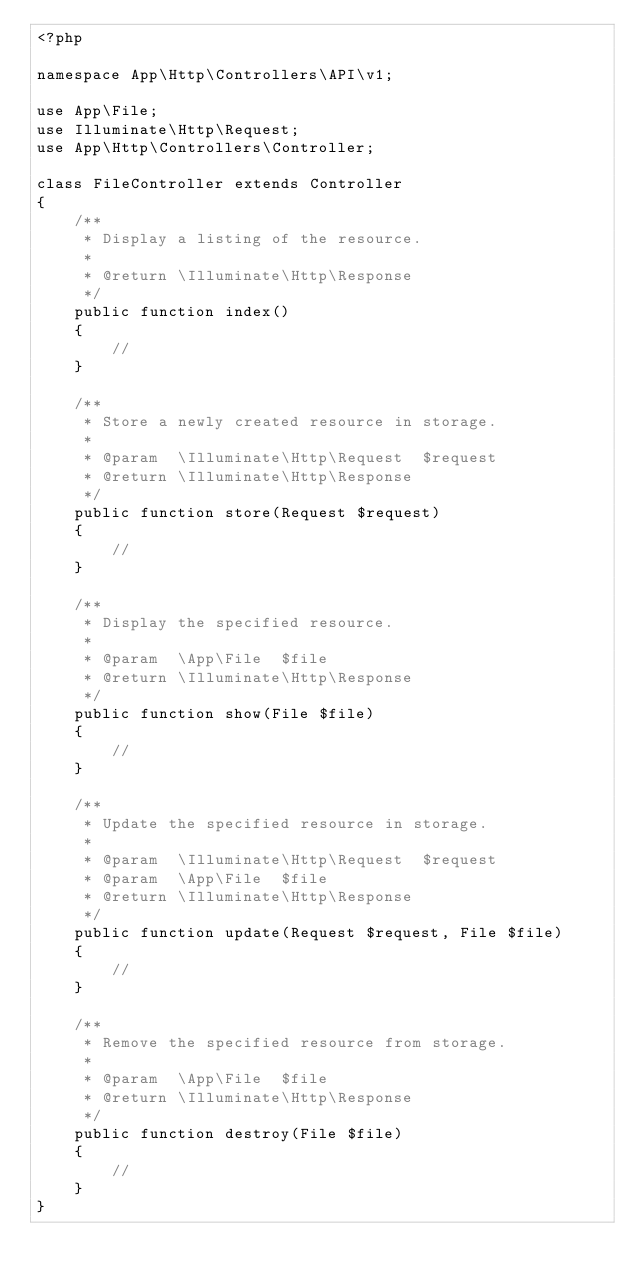<code> <loc_0><loc_0><loc_500><loc_500><_PHP_><?php

namespace App\Http\Controllers\API\v1;

use App\File;
use Illuminate\Http\Request;
use App\Http\Controllers\Controller;

class FileController extends Controller
{
    /**
     * Display a listing of the resource.
     *
     * @return \Illuminate\Http\Response
     */
    public function index()
    {
        //
    }

    /**
     * Store a newly created resource in storage.
     *
     * @param  \Illuminate\Http\Request  $request
     * @return \Illuminate\Http\Response
     */
    public function store(Request $request)
    {
        //
    }

    /**
     * Display the specified resource.
     *
     * @param  \App\File  $file
     * @return \Illuminate\Http\Response
     */
    public function show(File $file)
    {
        //
    }

    /**
     * Update the specified resource in storage.
     *
     * @param  \Illuminate\Http\Request  $request
     * @param  \App\File  $file
     * @return \Illuminate\Http\Response
     */
    public function update(Request $request, File $file)
    {
        //
    }

    /**
     * Remove the specified resource from storage.
     *
     * @param  \App\File  $file
     * @return \Illuminate\Http\Response
     */
    public function destroy(File $file)
    {
        //
    }
}
</code> 